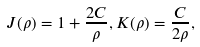<formula> <loc_0><loc_0><loc_500><loc_500>J ( \rho ) = 1 + \frac { 2 C } { \rho } , K ( \rho ) = \frac { C } { 2 \rho } ,</formula> 